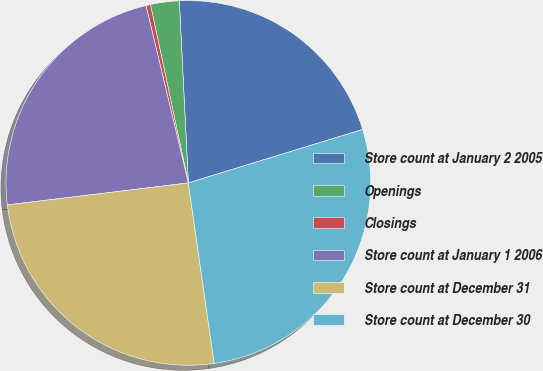Convert chart. <chart><loc_0><loc_0><loc_500><loc_500><pie_chart><fcel>Store count at January 2 2005<fcel>Openings<fcel>Closings<fcel>Store count at January 1 2006<fcel>Store count at December 31<fcel>Store count at December 30<nl><fcel>21.05%<fcel>2.54%<fcel>0.4%<fcel>23.19%<fcel>25.33%<fcel>27.47%<nl></chart> 